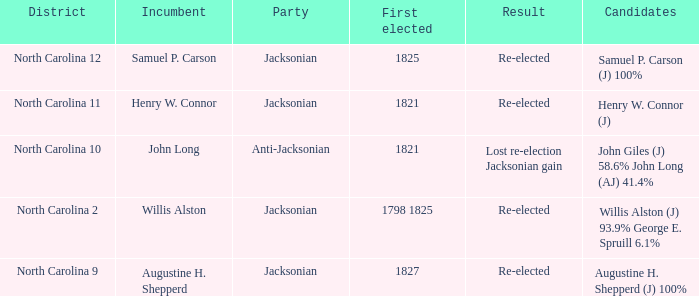Name the total number of party for willis alston (j) 93.9% george e. spruill 6.1% 1.0. 